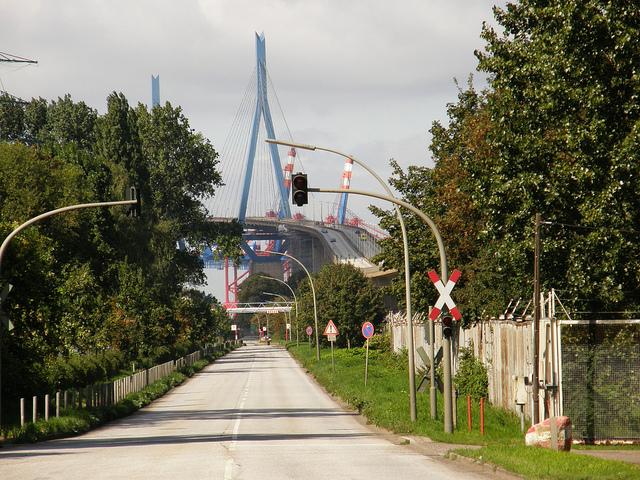Is it a sunny day?
Give a very brief answer. Yes. What shape is the red and white sign?
Keep it brief. X. Where are the street signs?
Quick response, please. On pole. 